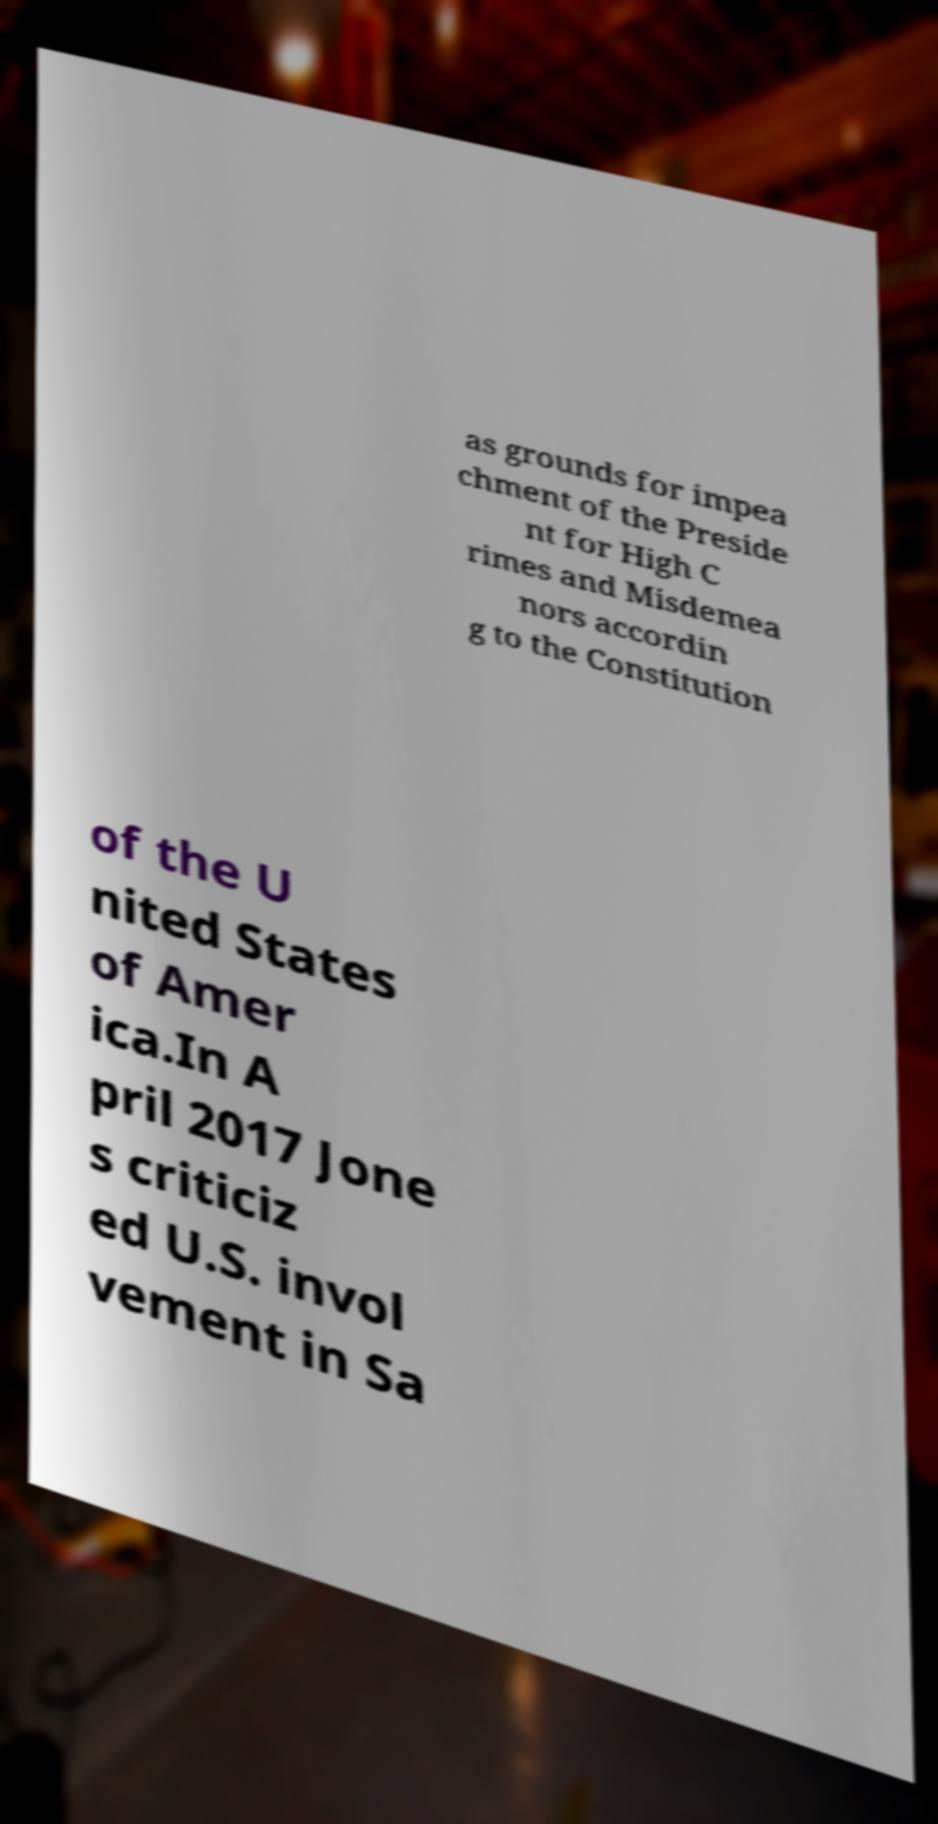Please read and relay the text visible in this image. What does it say? as grounds for impea chment of the Preside nt for High C rimes and Misdemea nors accordin g to the Constitution of the U nited States of Amer ica.In A pril 2017 Jone s criticiz ed U.S. invol vement in Sa 